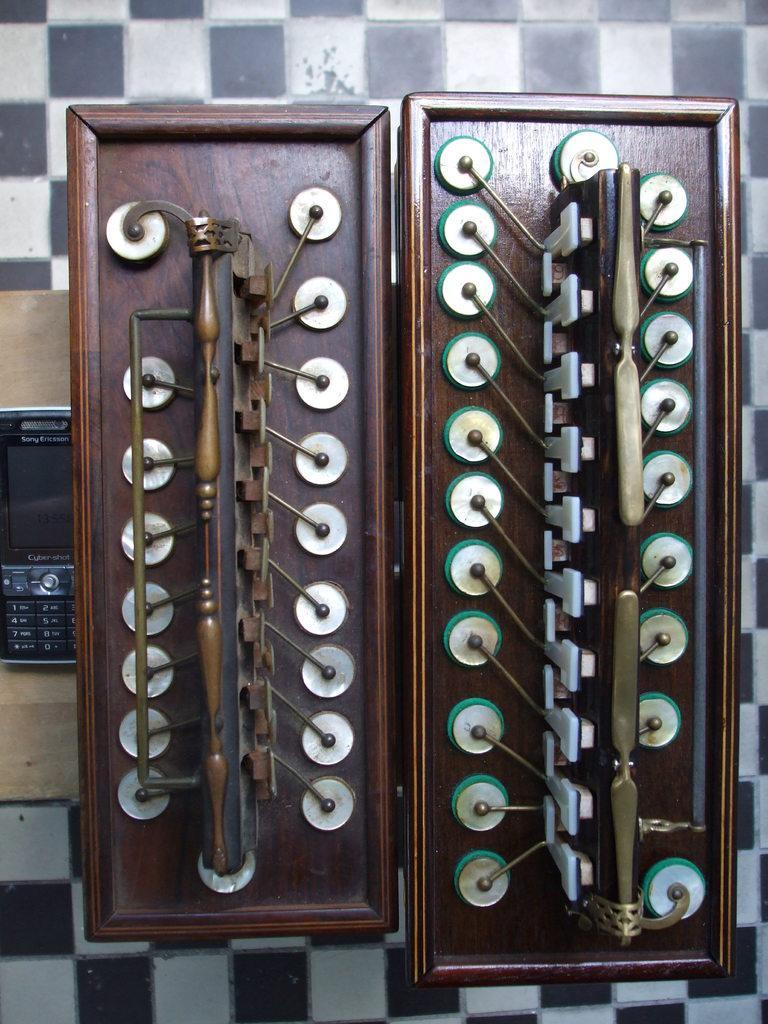Please provide a concise description of this image. In this image I can see there is a mobile on the left side and it is placed on the wooden surface and it looks like there is a musical instrument at the right side. 